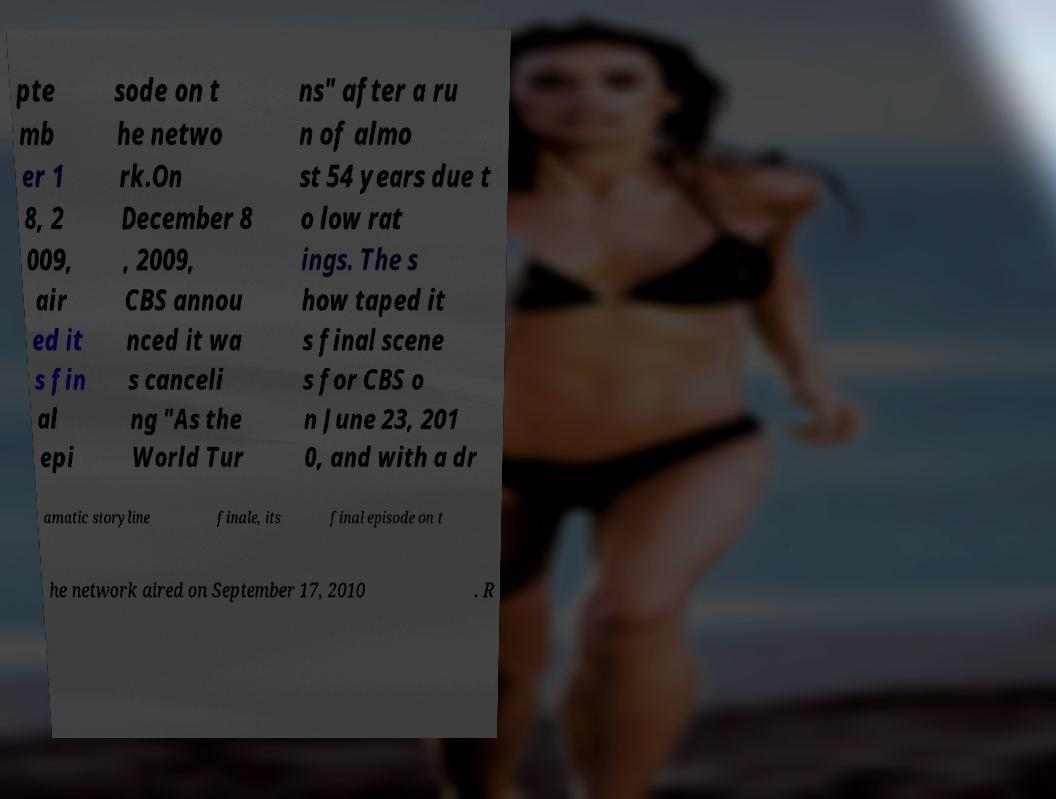Can you read and provide the text displayed in the image?This photo seems to have some interesting text. Can you extract and type it out for me? pte mb er 1 8, 2 009, air ed it s fin al epi sode on t he netwo rk.On December 8 , 2009, CBS annou nced it wa s canceli ng "As the World Tur ns" after a ru n of almo st 54 years due t o low rat ings. The s how taped it s final scene s for CBS o n June 23, 201 0, and with a dr amatic storyline finale, its final episode on t he network aired on September 17, 2010 . R 